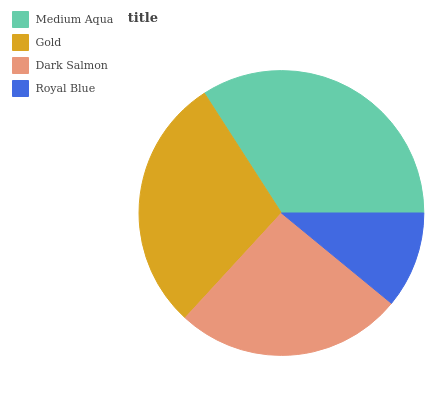Is Royal Blue the minimum?
Answer yes or no. Yes. Is Medium Aqua the maximum?
Answer yes or no. Yes. Is Gold the minimum?
Answer yes or no. No. Is Gold the maximum?
Answer yes or no. No. Is Medium Aqua greater than Gold?
Answer yes or no. Yes. Is Gold less than Medium Aqua?
Answer yes or no. Yes. Is Gold greater than Medium Aqua?
Answer yes or no. No. Is Medium Aqua less than Gold?
Answer yes or no. No. Is Gold the high median?
Answer yes or no. Yes. Is Dark Salmon the low median?
Answer yes or no. Yes. Is Royal Blue the high median?
Answer yes or no. No. Is Royal Blue the low median?
Answer yes or no. No. 